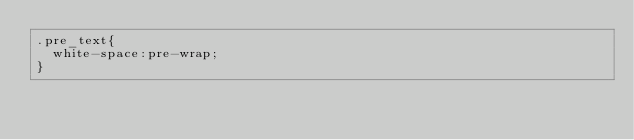Convert code to text. <code><loc_0><loc_0><loc_500><loc_500><_CSS_>.pre_text{
	white-space:pre-wrap;
}</code> 